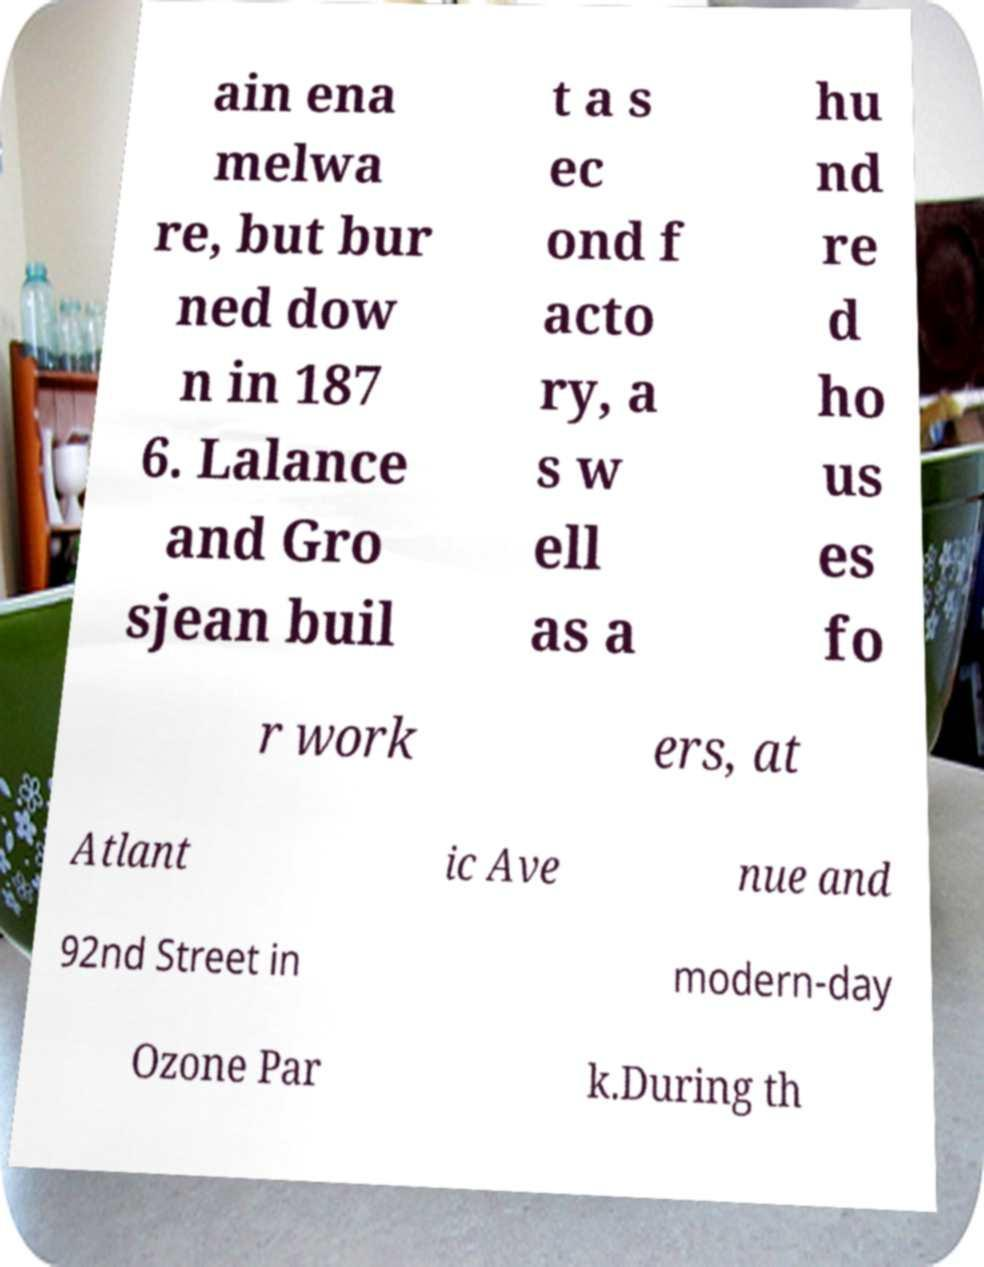Could you extract and type out the text from this image? ain ena melwa re, but bur ned dow n in 187 6. Lalance and Gro sjean buil t a s ec ond f acto ry, a s w ell as a hu nd re d ho us es fo r work ers, at Atlant ic Ave nue and 92nd Street in modern-day Ozone Par k.During th 